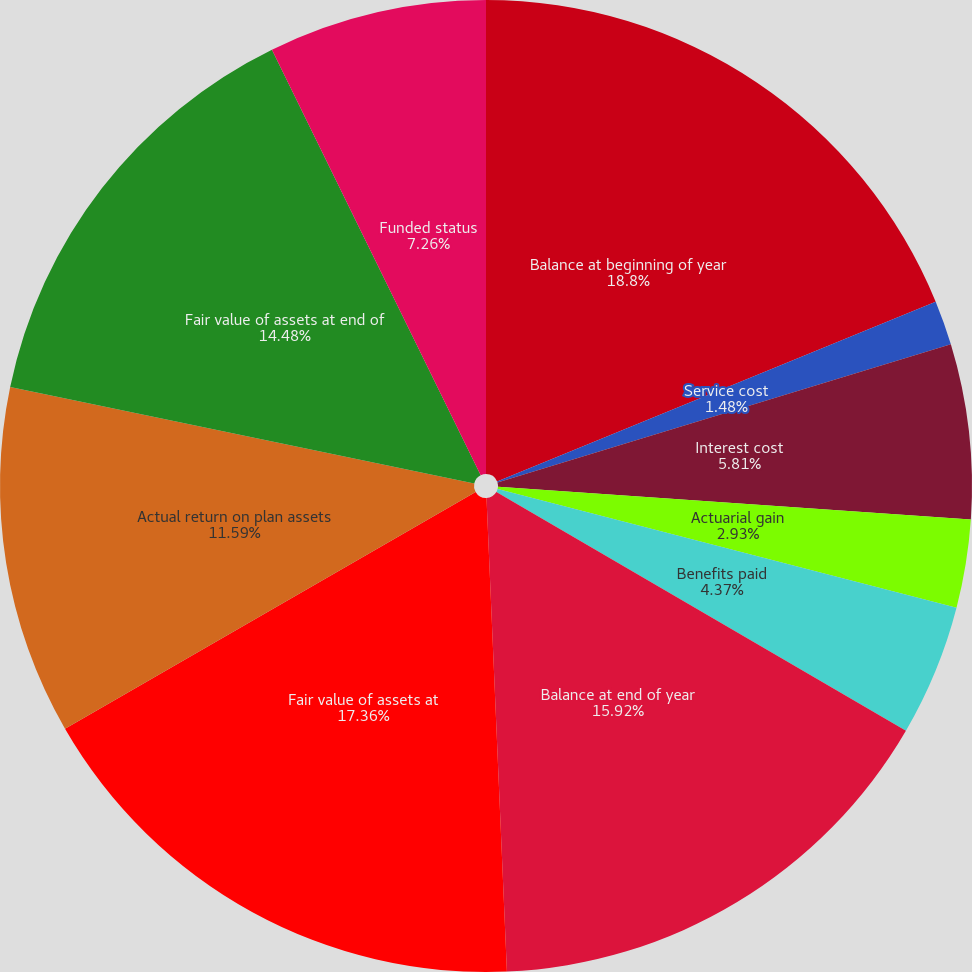Convert chart to OTSL. <chart><loc_0><loc_0><loc_500><loc_500><pie_chart><fcel>Balance at beginning of year<fcel>Service cost<fcel>Interest cost<fcel>Actuarial gain<fcel>Benefits paid<fcel>Balance at end of year<fcel>Fair value of assets at<fcel>Actual return on plan assets<fcel>Fair value of assets at end of<fcel>Funded status<nl><fcel>18.81%<fcel>1.48%<fcel>5.81%<fcel>2.93%<fcel>4.37%<fcel>15.92%<fcel>17.36%<fcel>11.59%<fcel>14.48%<fcel>7.26%<nl></chart> 